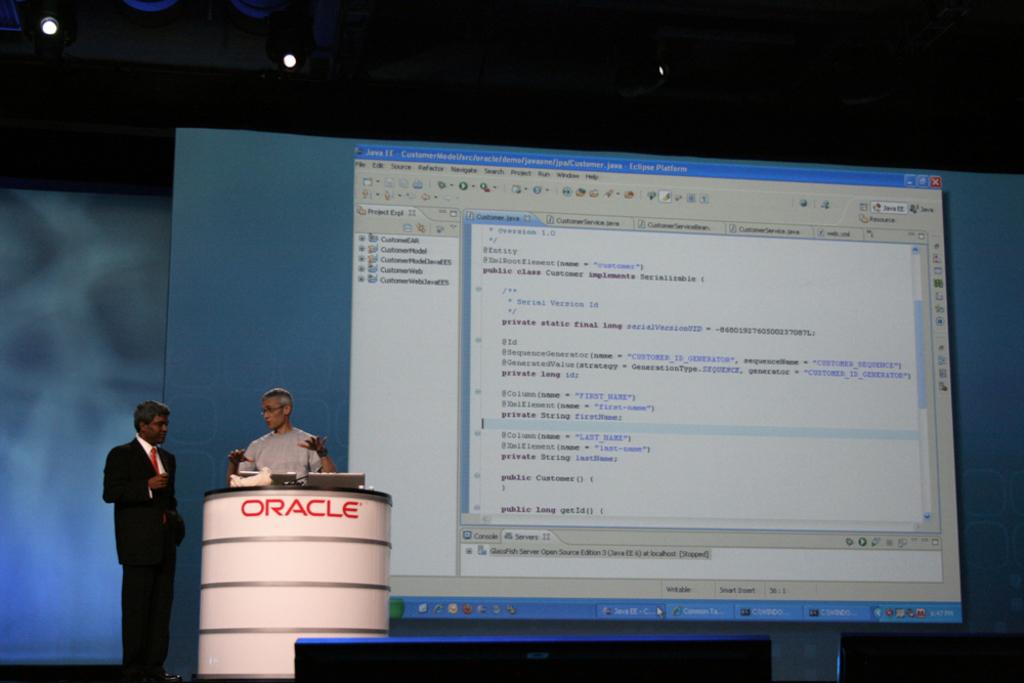What company is this for?
Your answer should be very brief. Oracle. What does it say on the podium?
Ensure brevity in your answer.  Oracle. 